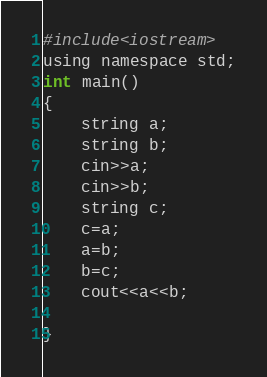<code> <loc_0><loc_0><loc_500><loc_500><_Awk_>#include<iostream>
using namespace std;
int main()
{
	string a;
	string b;
	cin>>a;
	cin>>b;
	string c;
	c=a;
	a=b;
	b=c;
	cout<<a<<b;
	
}</code> 